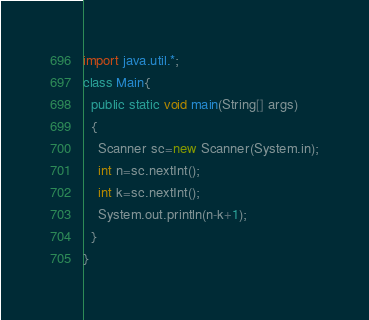<code> <loc_0><loc_0><loc_500><loc_500><_Java_>import java.util.*;
class Main{
  public static void main(String[] args)
  {
    Scanner sc=new Scanner(System.in);
    int n=sc.nextInt();
    int k=sc.nextInt();
    System.out.println(n-k+1);
  }
}
</code> 